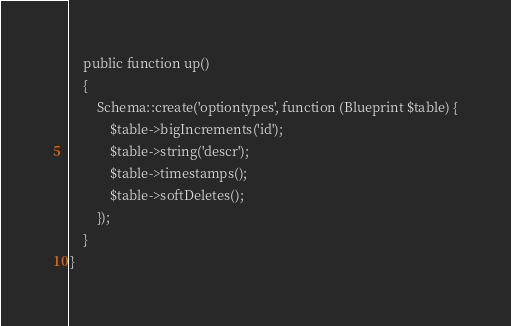<code> <loc_0><loc_0><loc_500><loc_500><_PHP_>    public function up()
    {
        Schema::create('optiontypes', function (Blueprint $table) {
            $table->bigIncrements('id');
            $table->string('descr');
            $table->timestamps();
            $table->softDeletes();
        });
    }
}
</code> 